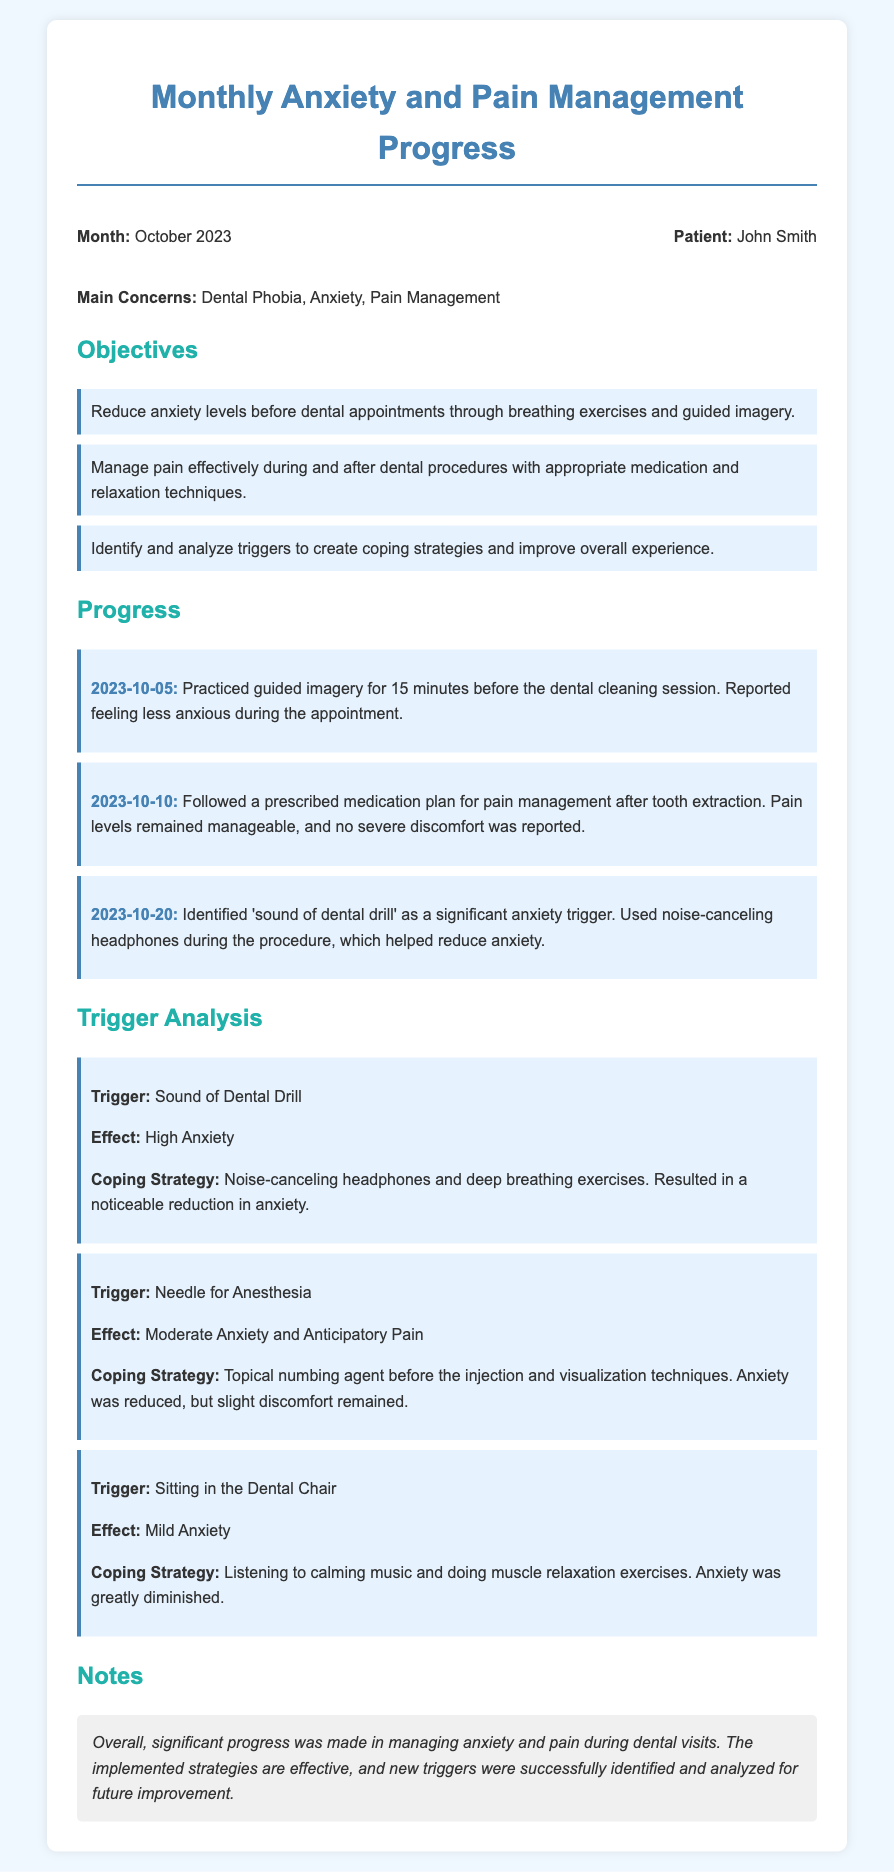What is the patient's name? The patient's name is mentioned at the beginning of the document.
Answer: John Smith What is the main concern addressed in the document? The main concern is highlighted in the introductory section of the document.
Answer: Dental Phobia On what date did the patient use guided imagery? The specific date is noted in the progress section of the document.
Answer: 2023-10-05 How effective was the medication plan after the tooth extraction? The effectiveness of the medication plan is summarized in one of the progress items.
Answer: Manageable What coping strategy was used for the 'sound of dental drill' trigger? The coping strategy is detailed under the trigger analysis section of the document.
Answer: Noise-canceling headphones and deep breathing exercises Which trigger caused moderate anxiety? The specific trigger is identified in the trigger analysis section.
Answer: Needle for Anesthesia What is the effect of sitting in the dental chair? The effect of this trigger is described in the trigger analysis section.
Answer: Mild Anxiety What significant progress was noted in the notes section? The notes section summarizes the key point of progress made in managing anxiety and pain.
Answer: Significant progress What relaxation technique was used while sitting in the dental chair? The specific relaxation technique is mentioned in the trigger analysis section.
Answer: Muscle relaxation exercises 